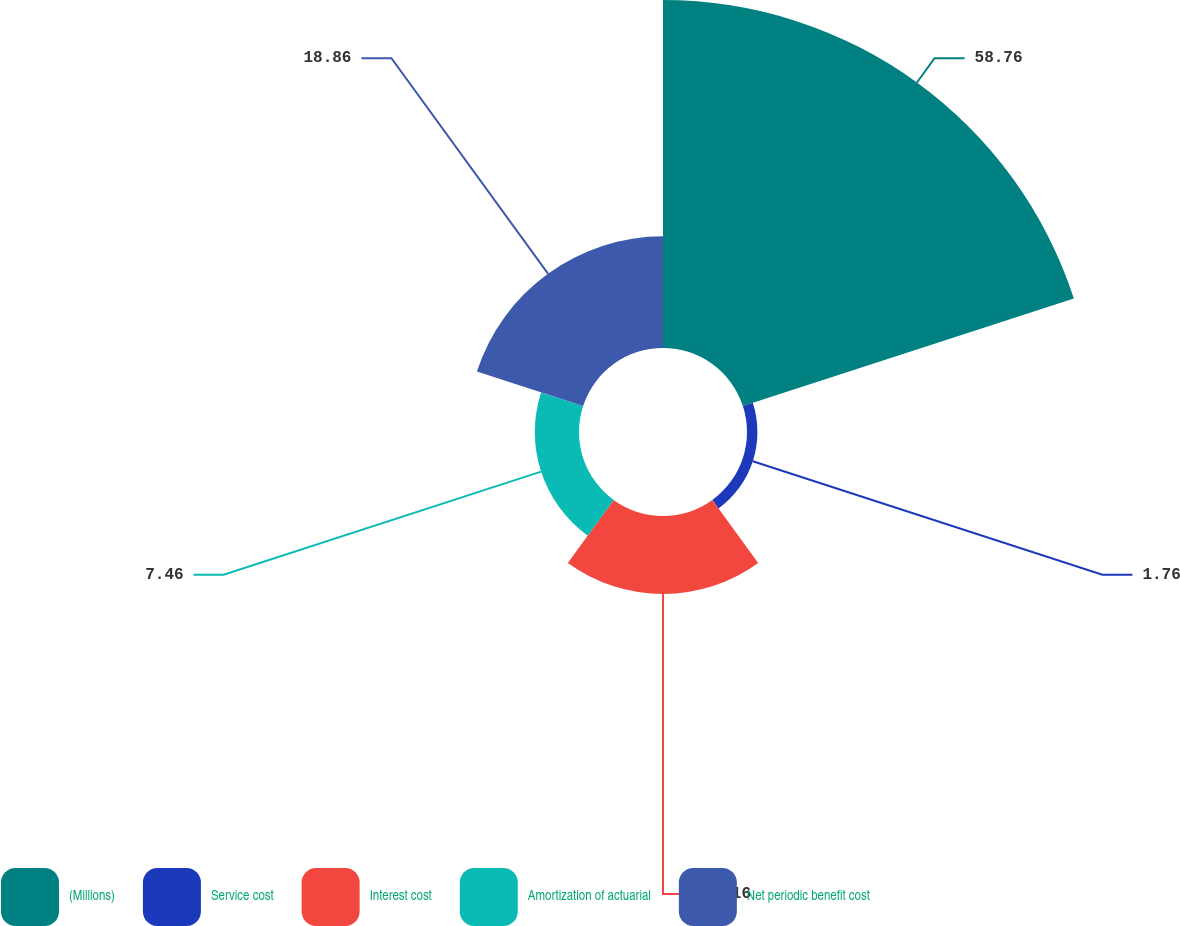Convert chart. <chart><loc_0><loc_0><loc_500><loc_500><pie_chart><fcel>(Millions)<fcel>Service cost<fcel>Interest cost<fcel>Amortization of actuarial<fcel>Net periodic benefit cost<nl><fcel>58.76%<fcel>1.76%<fcel>13.16%<fcel>7.46%<fcel>18.86%<nl></chart> 